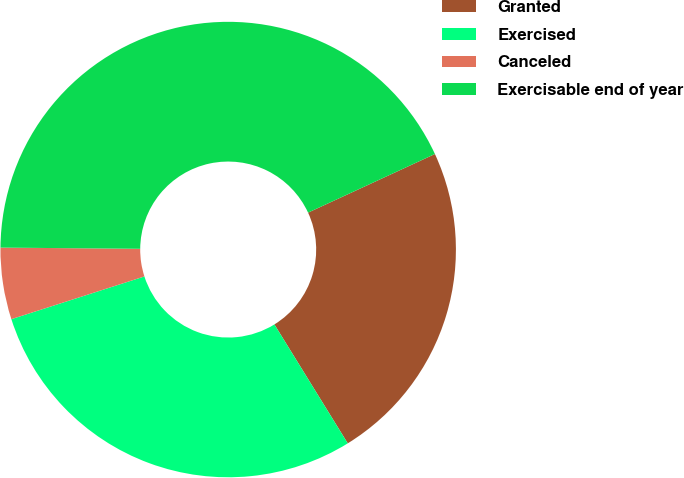<chart> <loc_0><loc_0><loc_500><loc_500><pie_chart><fcel>Granted<fcel>Exercised<fcel>Canceled<fcel>Exercisable end of year<nl><fcel>23.09%<fcel>28.85%<fcel>5.08%<fcel>42.97%<nl></chart> 